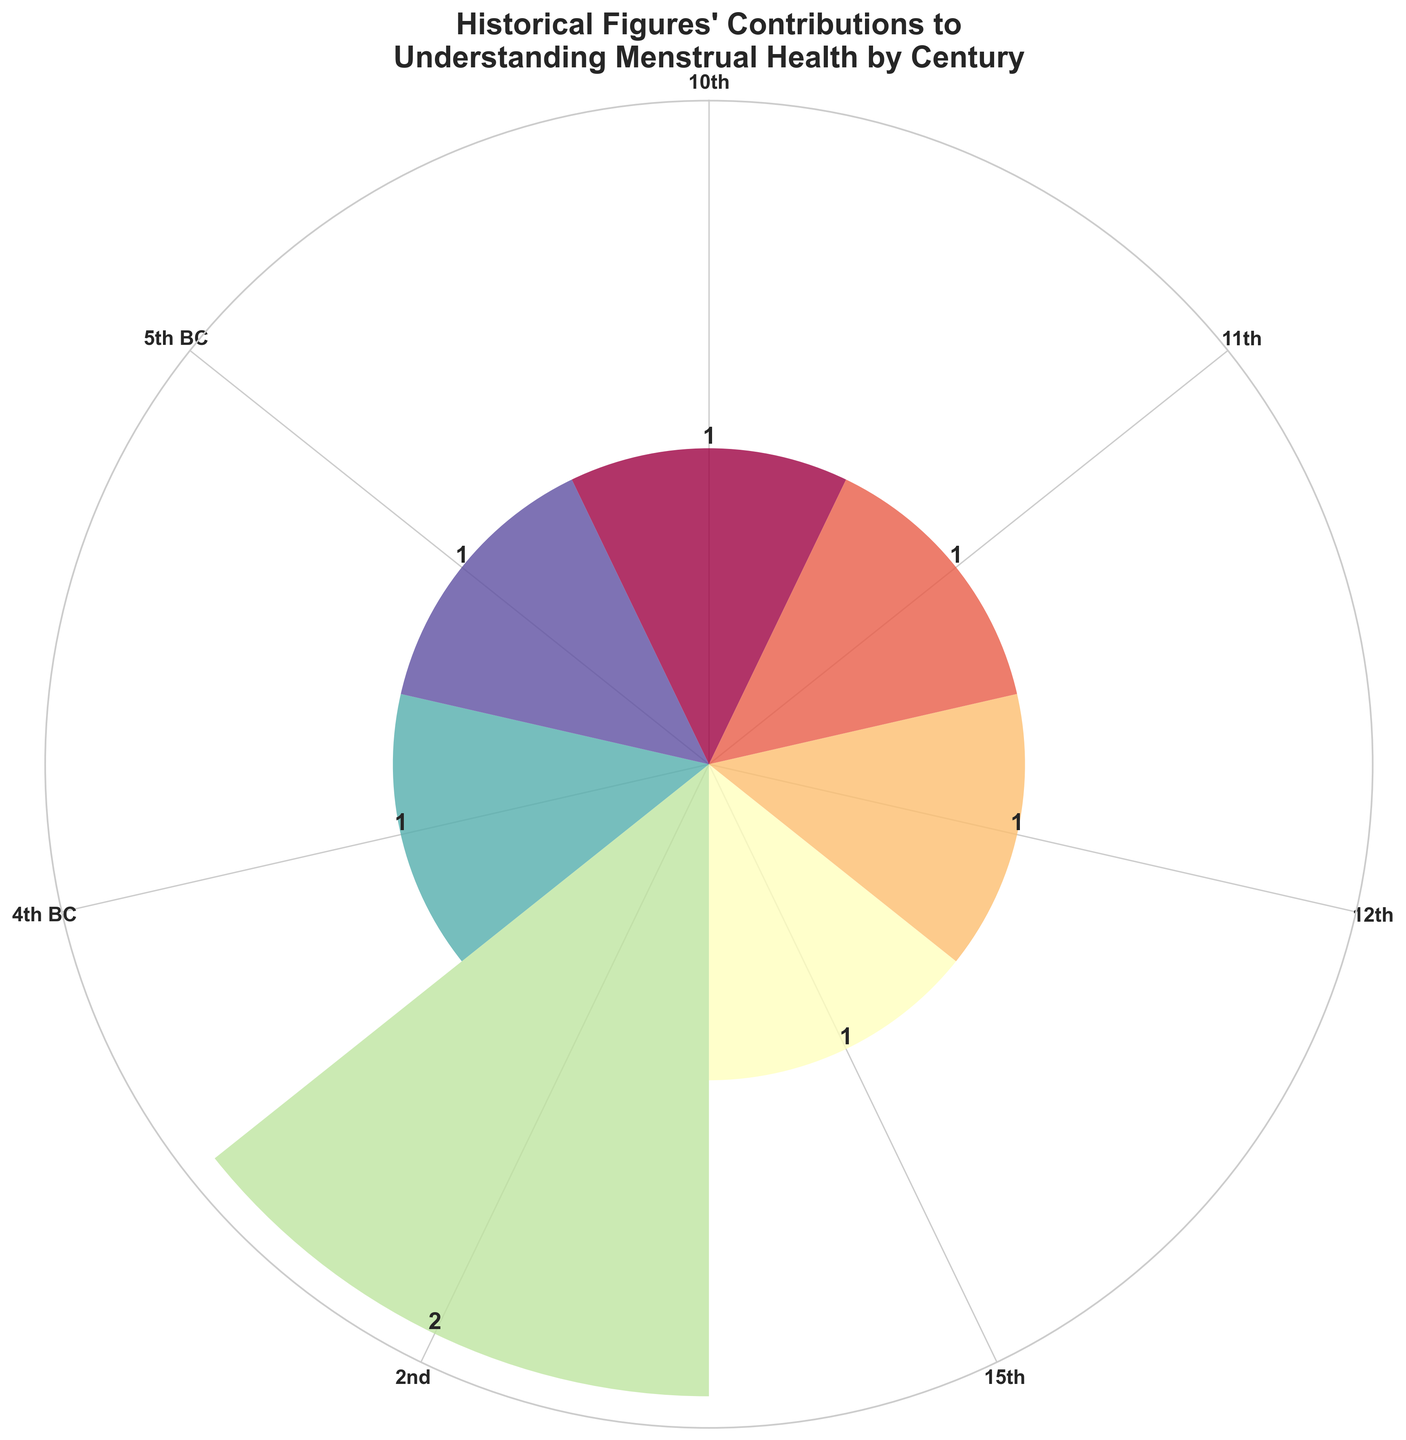Which century has the most contributions to understanding menstrual health according to the figure? The height of the bars represents the number of contributions for each century. The century with the highest bar (maximum height) has the most contributions.
Answer: 2nd century What is the total number of historical figures included in the figure? Count the numbers above each bar from all centuries and sum them up.
Answer: 8 How many contributions are there in the centuries before the 10th century? Add the contributions from the 5th century BC, 4th century BC, and 2nd century. Summing the counts gives the total number of contributions.
Answer: 5 Which centuries have only one contribution each? Identify the bars with a height of 1 and read the corresponding century labels from the x-axis ticks.
Answer: 10th century, 15th century, 11th century What is the difference in the number of contributions between the 2nd century and the 12th century? Subtract the number of contributions in the 12th century from those in the 2nd century.
Answer: 1 (2nd century has 2, 12th century has 1) How many centuries are represented in the figure? Count the distinct century labels on the x-axis.
Answer: 6 Are there more contributions in BC or AD centuries? Sum the contributions from BC (5th and 4th centuries) and compare with the sum from AD centuries.
Answer: AD centuries (6 vs 2) Which century has the second-highest number of contributions and how many? Identify the century with the second-tallest bar and read the count.
Answer: 12th century, 1 What is the average number of contributions per century? Sum the total contributions and divide by the number of centuries. (8 contributions in 6 centuries, so 8/6)
Answer: 1.33 Is there a century with more than one contribution, and if so, which one? Check the bars for any height greater than 1 and identify the corresponding century.
Answer: 2nd century 